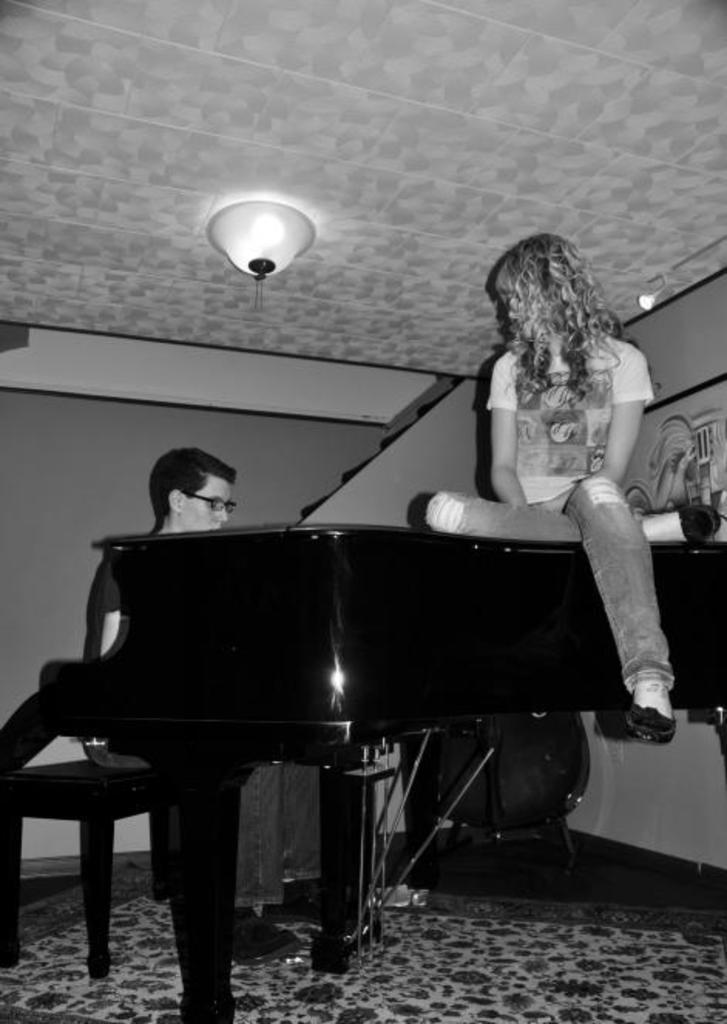Can you describe this image briefly? This picture describes a girl sitting in the piano and a boy sitting in the chair and playing the piano and at the back ground there is a stair case ,a photo frame attached to the wall a light attached to the ceiling and a carpet. 